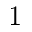Convert formula to latex. <formula><loc_0><loc_0><loc_500><loc_500>1</formula> 